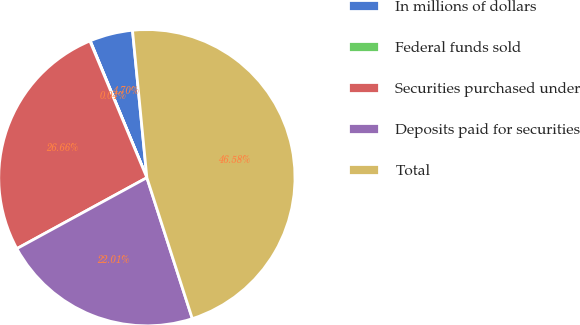<chart> <loc_0><loc_0><loc_500><loc_500><pie_chart><fcel>In millions of dollars<fcel>Federal funds sold<fcel>Securities purchased under<fcel>Deposits paid for securities<fcel>Total<nl><fcel>4.7%<fcel>0.04%<fcel>26.66%<fcel>22.01%<fcel>46.58%<nl></chart> 